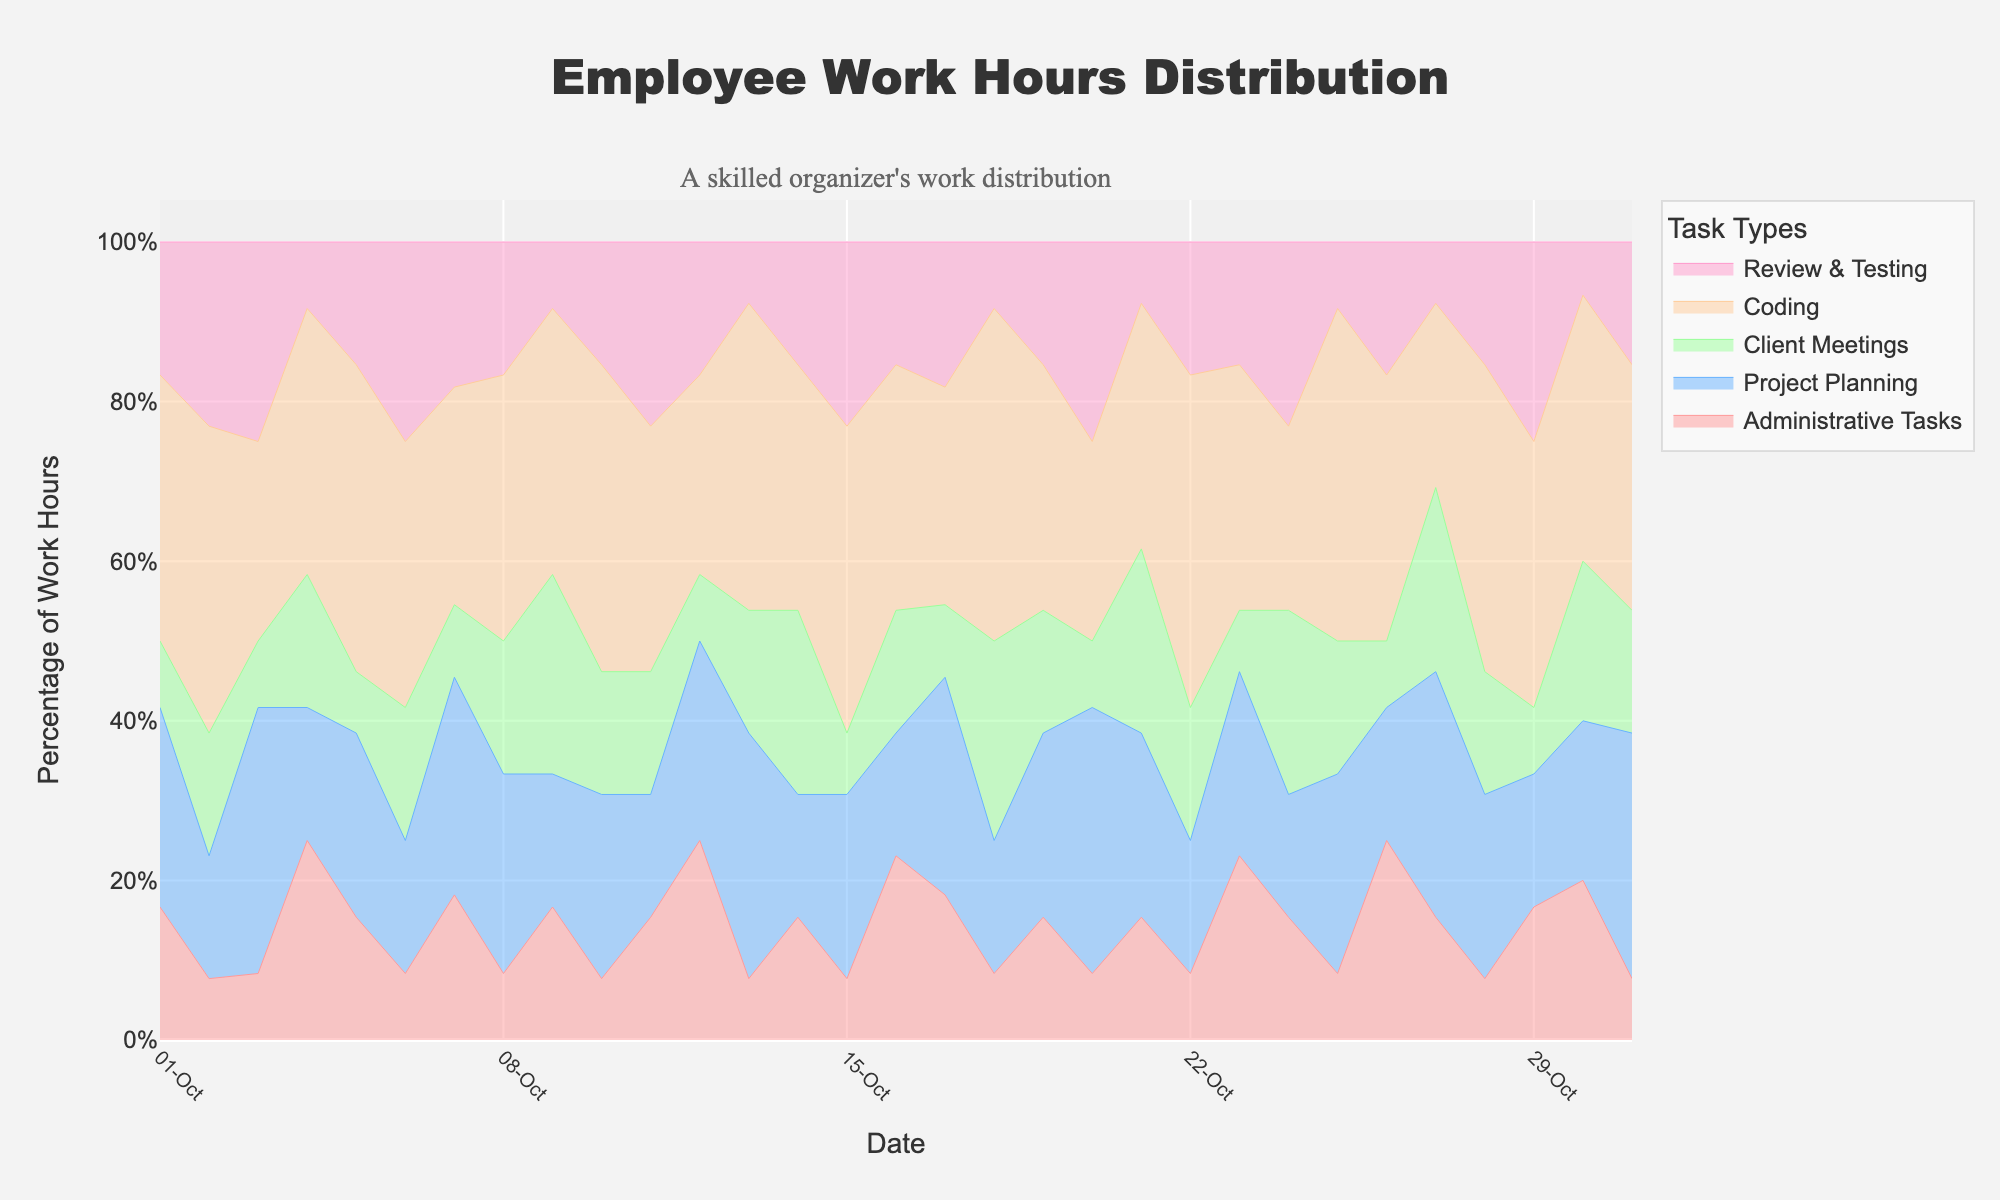What is the title of the chart? The title of the chart is displayed prominently at the top. It reads "Employee Work Hours Distribution".
Answer: Employee Work Hours Distribution What are the time periods represented on the x-axis? The x-axis represents the dates from October 1st to October 31st. These are labeled in a slightly angled format for better readability.
Answer: October 1st to October 31st Which task type has the highest average percentage of work hours over the month? Analyzing the stacked areas, the "Coding" task type consistently occupies a larger portion of the chart. By observing the visual trends, it is evident that "Coding" regularly takes up the most space.
Answer: Coding How many task types are represented in this chart? The legend to the right of the chart lists all the task types. There are five task types: "Administrative Tasks", "Project Planning", "Client Meetings", "Coding", and "Review & Testing".
Answer: Five On which date did "Review & Testing" have the highest percentage of work hours? By examining the height of the "Review & Testing" area (light pink) along the y-axis across various dates, the largest span appears to be on October 2nd.
Answer: October 2nd How does the percentage of time spent on "Client Meetings" compare from October 10th to October 11th? Observing the blue area for "Client Meetings" between October 10th and October 11th, it is seen that the area remains relatively constant, indicating a similar percentage of time spent.
Answer: Similar On October 13th, which task type had the least percentage of work hours? On October 13th, the lowest visible area is "Administrative Tasks" (red), making it the task with the least percentage that day.
Answer: Administrative Tasks Which date had the most balanced distribution of task types? By visually inspecting the areas, October 27th shows a relatively even distribution among all task types with no overly dominant area.
Answer: October 27th What changes in the percentage of time spent on "Project Planning" from October 20th to October 21st? Observing the green area for "Project Planning", there is a decrease in its portion from October 20th to October 21st.
Answer: Decrease Is there a noticeable trend for "Administrative Tasks" over the month? The red area representing "Administrative Tasks" appears fairly consistent without significant fluctuations, indicating a steady percentage each day.
Answer: Steady 